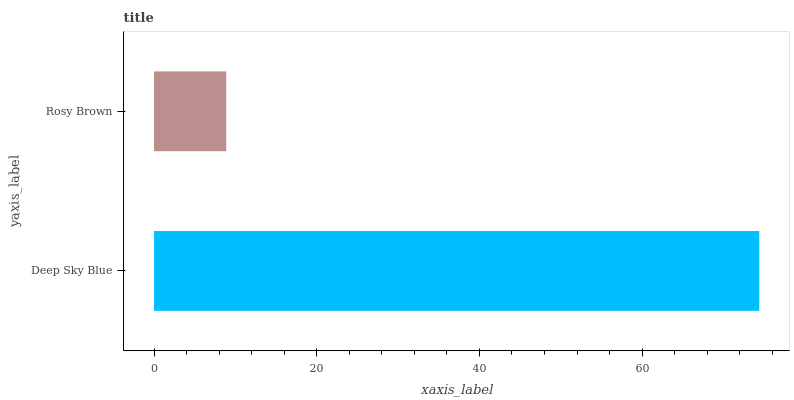Is Rosy Brown the minimum?
Answer yes or no. Yes. Is Deep Sky Blue the maximum?
Answer yes or no. Yes. Is Rosy Brown the maximum?
Answer yes or no. No. Is Deep Sky Blue greater than Rosy Brown?
Answer yes or no. Yes. Is Rosy Brown less than Deep Sky Blue?
Answer yes or no. Yes. Is Rosy Brown greater than Deep Sky Blue?
Answer yes or no. No. Is Deep Sky Blue less than Rosy Brown?
Answer yes or no. No. Is Deep Sky Blue the high median?
Answer yes or no. Yes. Is Rosy Brown the low median?
Answer yes or no. Yes. Is Rosy Brown the high median?
Answer yes or no. No. Is Deep Sky Blue the low median?
Answer yes or no. No. 